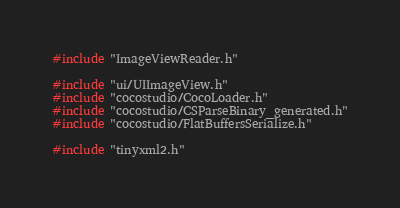<code> <loc_0><loc_0><loc_500><loc_500><_C++_>

#include "ImageViewReader.h"

#include "ui/UIImageView.h"
#include "cocostudio/CocoLoader.h"
#include "cocostudio/CSParseBinary_generated.h"
#include "cocostudio/FlatBuffersSerialize.h"

#include "tinyxml2.h"</code> 